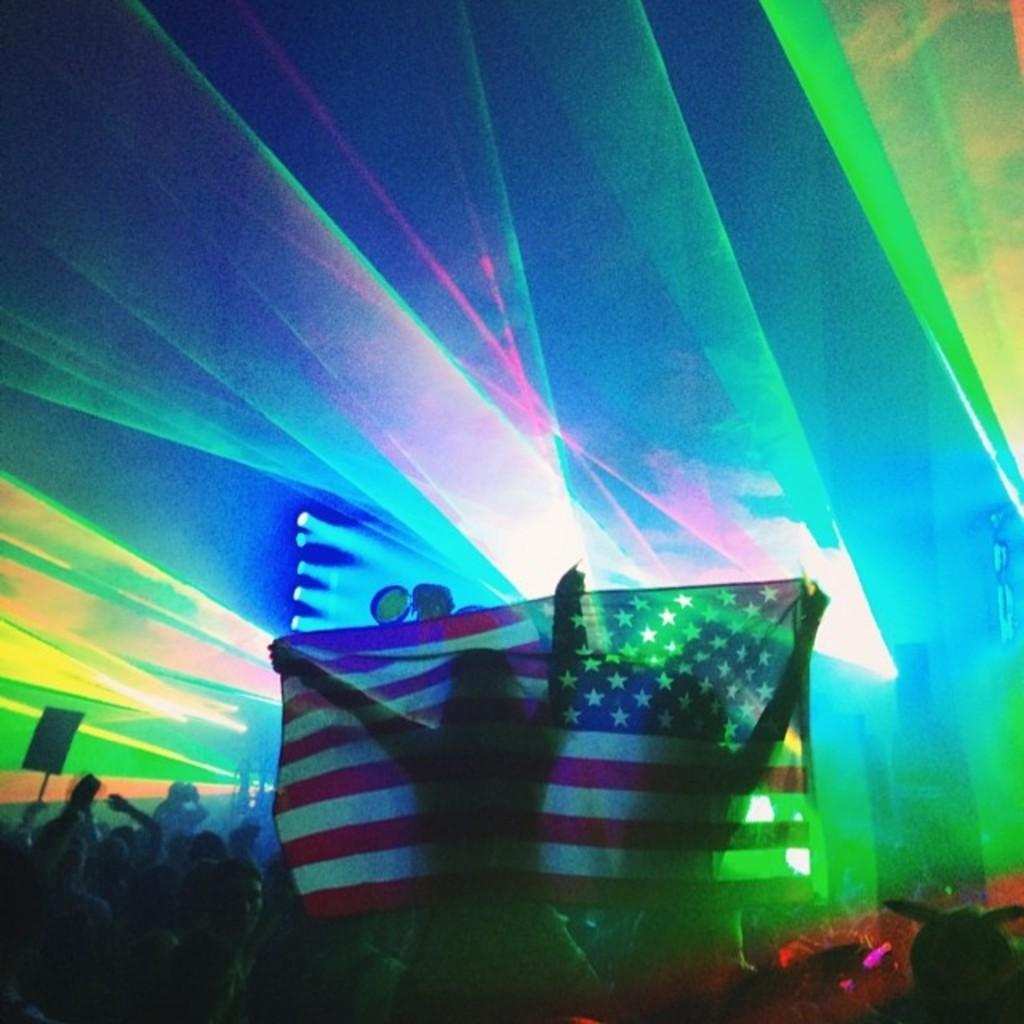What is the main subject of the image? The main subject of the image is a crowd. What are some people in the crowd doing? Some people in the crowd are holding a flag. What can be seen in the background of the image? There are lights visible in the background, and there is an object in the background. What type of basketball game is being played in the image? There is no basketball game present in the image; it features a crowd with people holding a flag. What color is the hope depicted in the image? The concept of hope is not a visual element that can be depicted in an image, so it cannot be described in terms of color. 